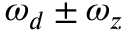Convert formula to latex. <formula><loc_0><loc_0><loc_500><loc_500>\omega _ { d } \pm \omega _ { z }</formula> 